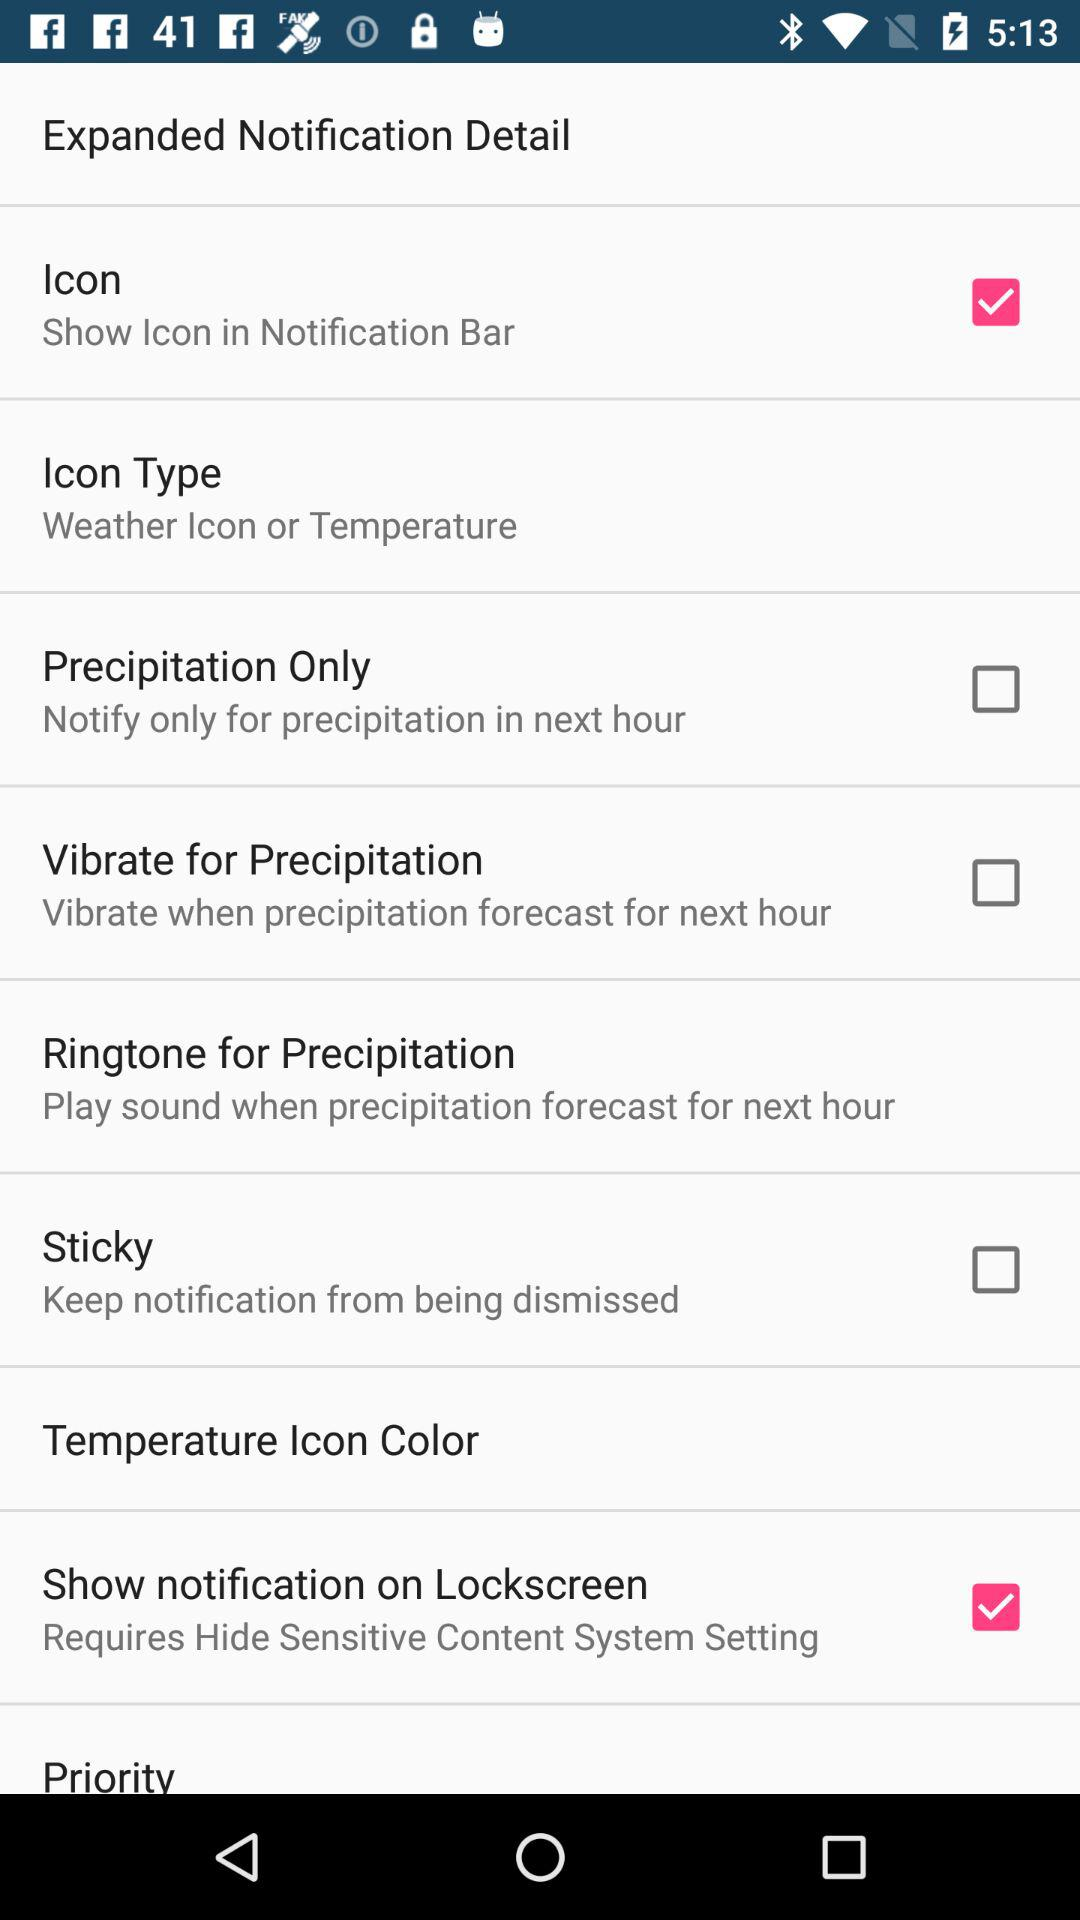What is the status of the "Lockscreen"? The status is "on". 